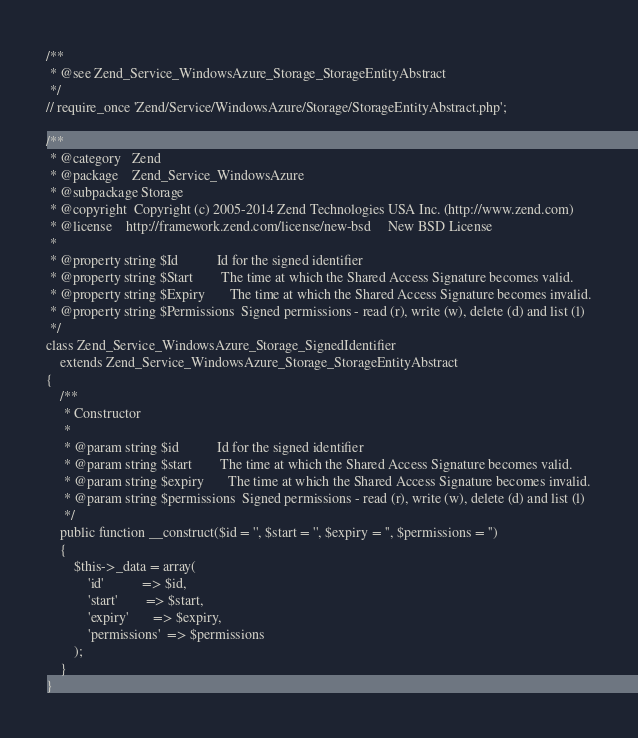<code> <loc_0><loc_0><loc_500><loc_500><_PHP_>
/**
 * @see Zend_Service_WindowsAzure_Storage_StorageEntityAbstract
 */
// require_once 'Zend/Service/WindowsAzure/Storage/StorageEntityAbstract.php';

/**
 * @category   Zend
 * @package    Zend_Service_WindowsAzure
 * @subpackage Storage
 * @copyright  Copyright (c) 2005-2014 Zend Technologies USA Inc. (http://www.zend.com)
 * @license    http://framework.zend.com/license/new-bsd     New BSD License
 * 
 * @property string $Id           Id for the signed identifier
 * @property string $Start        The time at which the Shared Access Signature becomes valid.
 * @property string $Expiry       The time at which the Shared Access Signature becomes invalid.
 * @property string $Permissions  Signed permissions - read (r), write (w), delete (d) and list (l)
 */
class Zend_Service_WindowsAzure_Storage_SignedIdentifier
	extends Zend_Service_WindowsAzure_Storage_StorageEntityAbstract
{
    /**
     * Constructor
     * 
     * @param string $id           Id for the signed identifier
     * @param string $start        The time at which the Shared Access Signature becomes valid.
     * @param string $expiry       The time at which the Shared Access Signature becomes invalid.
     * @param string $permissions  Signed permissions - read (r), write (w), delete (d) and list (l)
     */
    public function __construct($id = '', $start = '', $expiry = '', $permissions = '') 
    {
        $this->_data = array(
            'id'           => $id,
            'start'        => $start,
            'expiry'       => $expiry,
            'permissions'  => $permissions
        );
    }
}
</code> 